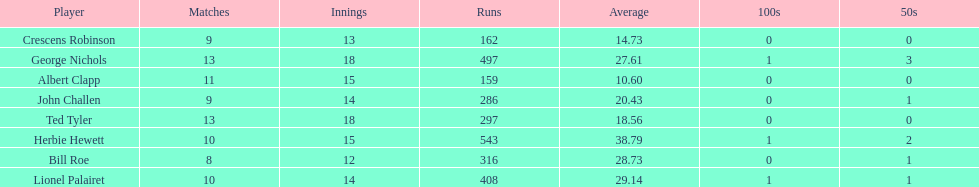Name a player that play in no more than 13 innings. Bill Roe. 